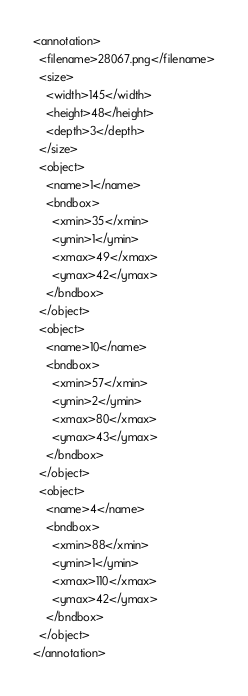Convert code to text. <code><loc_0><loc_0><loc_500><loc_500><_XML_><annotation>
  <filename>28067.png</filename>
  <size>
    <width>145</width>
    <height>48</height>
    <depth>3</depth>
  </size>
  <object>
    <name>1</name>
    <bndbox>
      <xmin>35</xmin>
      <ymin>1</ymin>
      <xmax>49</xmax>
      <ymax>42</ymax>
    </bndbox>
  </object>
  <object>
    <name>10</name>
    <bndbox>
      <xmin>57</xmin>
      <ymin>2</ymin>
      <xmax>80</xmax>
      <ymax>43</ymax>
    </bndbox>
  </object>
  <object>
    <name>4</name>
    <bndbox>
      <xmin>88</xmin>
      <ymin>1</ymin>
      <xmax>110</xmax>
      <ymax>42</ymax>
    </bndbox>
  </object>
</annotation>
</code> 